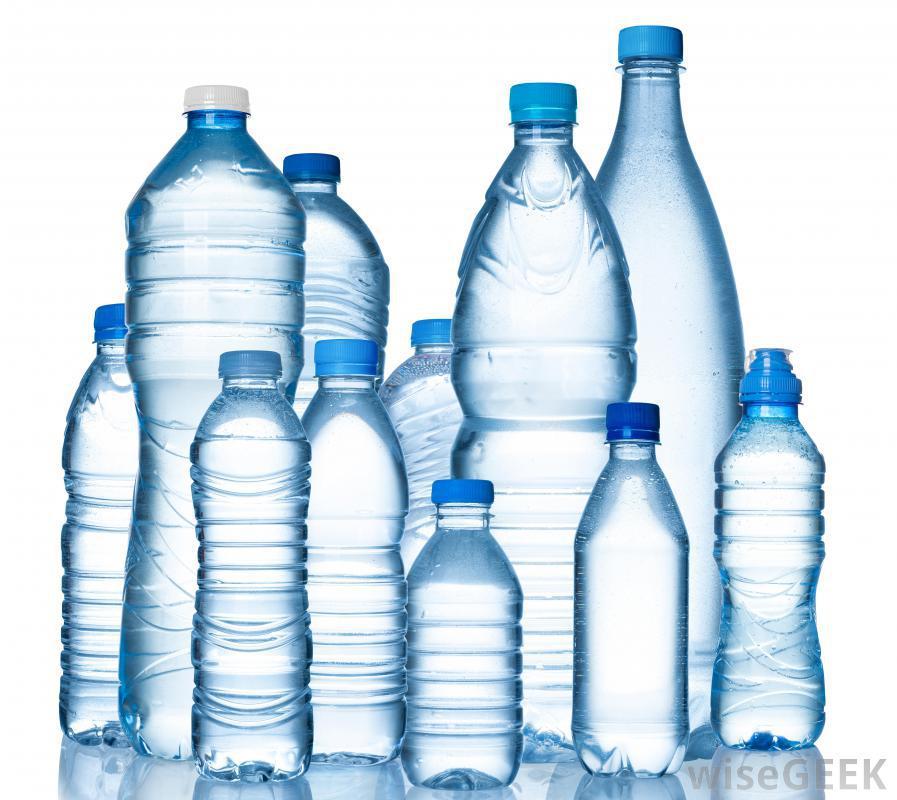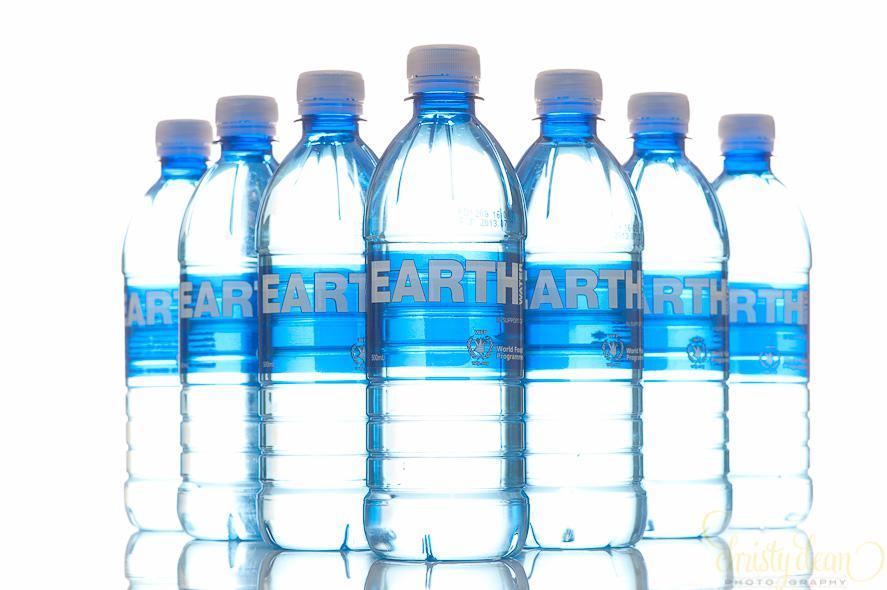The first image is the image on the left, the second image is the image on the right. For the images displayed, is the sentence "The left image shows 5 water bottles lined up in V-formation with the words, """"clear water"""" on them." factually correct? Answer yes or no. No. The first image is the image on the left, the second image is the image on the right. Considering the images on both sides, is "Five identical water bottles are in a V-formation in the image on the left." valid? Answer yes or no. No. 